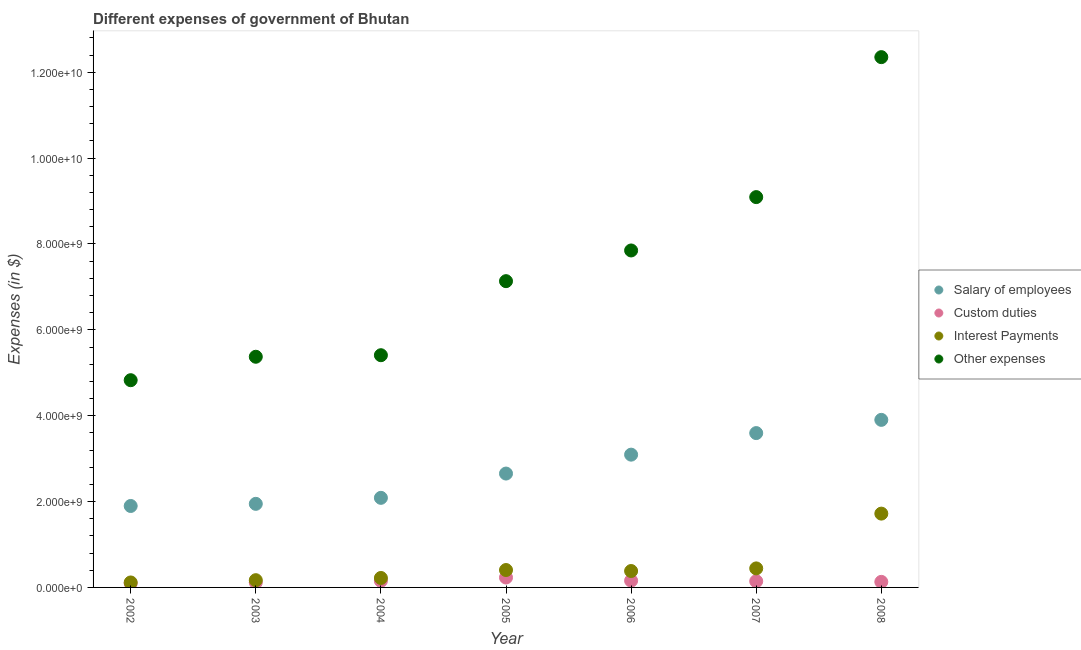What is the amount spent on salary of employees in 2006?
Offer a very short reply. 3.09e+09. Across all years, what is the maximum amount spent on other expenses?
Give a very brief answer. 1.24e+1. Across all years, what is the minimum amount spent on salary of employees?
Provide a succinct answer. 1.90e+09. In which year was the amount spent on interest payments maximum?
Ensure brevity in your answer.  2008. What is the total amount spent on custom duties in the graph?
Provide a succinct answer. 1.03e+09. What is the difference between the amount spent on salary of employees in 2006 and that in 2008?
Offer a very short reply. -8.10e+08. What is the difference between the amount spent on custom duties in 2007 and the amount spent on salary of employees in 2006?
Ensure brevity in your answer.  -2.95e+09. What is the average amount spent on other expenses per year?
Provide a succinct answer. 7.43e+09. In the year 2006, what is the difference between the amount spent on salary of employees and amount spent on interest payments?
Your response must be concise. 2.71e+09. What is the ratio of the amount spent on interest payments in 2004 to that in 2007?
Ensure brevity in your answer.  0.5. Is the amount spent on interest payments in 2005 less than that in 2007?
Keep it short and to the point. Yes. What is the difference between the highest and the second highest amount spent on salary of employees?
Ensure brevity in your answer.  3.08e+08. What is the difference between the highest and the lowest amount spent on salary of employees?
Your answer should be very brief. 2.01e+09. Is the amount spent on salary of employees strictly greater than the amount spent on interest payments over the years?
Provide a succinct answer. Yes. Is the amount spent on custom duties strictly less than the amount spent on other expenses over the years?
Offer a terse response. Yes. How many years are there in the graph?
Give a very brief answer. 7. What is the difference between two consecutive major ticks on the Y-axis?
Offer a very short reply. 2.00e+09. Does the graph contain any zero values?
Your answer should be very brief. No. Where does the legend appear in the graph?
Your answer should be compact. Center right. How many legend labels are there?
Provide a short and direct response. 4. How are the legend labels stacked?
Your answer should be very brief. Vertical. What is the title of the graph?
Offer a terse response. Different expenses of government of Bhutan. Does "Labor Taxes" appear as one of the legend labels in the graph?
Keep it short and to the point. No. What is the label or title of the X-axis?
Make the answer very short. Year. What is the label or title of the Y-axis?
Provide a short and direct response. Expenses (in $). What is the Expenses (in $) in Salary of employees in 2002?
Your answer should be compact. 1.90e+09. What is the Expenses (in $) of Custom duties in 2002?
Your answer should be compact. 9.45e+07. What is the Expenses (in $) of Interest Payments in 2002?
Give a very brief answer. 1.16e+08. What is the Expenses (in $) of Other expenses in 2002?
Make the answer very short. 4.83e+09. What is the Expenses (in $) in Salary of employees in 2003?
Give a very brief answer. 1.95e+09. What is the Expenses (in $) of Custom duties in 2003?
Your response must be concise. 1.15e+08. What is the Expenses (in $) in Interest Payments in 2003?
Offer a terse response. 1.69e+08. What is the Expenses (in $) of Other expenses in 2003?
Your response must be concise. 5.37e+09. What is the Expenses (in $) in Salary of employees in 2004?
Make the answer very short. 2.09e+09. What is the Expenses (in $) in Custom duties in 2004?
Your answer should be compact. 1.53e+08. What is the Expenses (in $) of Interest Payments in 2004?
Your answer should be compact. 2.20e+08. What is the Expenses (in $) of Other expenses in 2004?
Provide a short and direct response. 5.41e+09. What is the Expenses (in $) of Salary of employees in 2005?
Offer a terse response. 2.65e+09. What is the Expenses (in $) of Custom duties in 2005?
Offer a very short reply. 2.31e+08. What is the Expenses (in $) of Interest Payments in 2005?
Offer a terse response. 4.05e+08. What is the Expenses (in $) in Other expenses in 2005?
Your response must be concise. 7.13e+09. What is the Expenses (in $) of Salary of employees in 2006?
Give a very brief answer. 3.09e+09. What is the Expenses (in $) of Custom duties in 2006?
Provide a succinct answer. 1.57e+08. What is the Expenses (in $) of Interest Payments in 2006?
Provide a succinct answer. 3.82e+08. What is the Expenses (in $) in Other expenses in 2006?
Make the answer very short. 7.85e+09. What is the Expenses (in $) in Salary of employees in 2007?
Give a very brief answer. 3.60e+09. What is the Expenses (in $) in Custom duties in 2007?
Keep it short and to the point. 1.45e+08. What is the Expenses (in $) in Interest Payments in 2007?
Make the answer very short. 4.43e+08. What is the Expenses (in $) in Other expenses in 2007?
Give a very brief answer. 9.09e+09. What is the Expenses (in $) in Salary of employees in 2008?
Provide a succinct answer. 3.90e+09. What is the Expenses (in $) in Custom duties in 2008?
Offer a very short reply. 1.29e+08. What is the Expenses (in $) of Interest Payments in 2008?
Provide a short and direct response. 1.72e+09. What is the Expenses (in $) in Other expenses in 2008?
Provide a succinct answer. 1.24e+1. Across all years, what is the maximum Expenses (in $) of Salary of employees?
Provide a short and direct response. 3.90e+09. Across all years, what is the maximum Expenses (in $) in Custom duties?
Give a very brief answer. 2.31e+08. Across all years, what is the maximum Expenses (in $) of Interest Payments?
Provide a succinct answer. 1.72e+09. Across all years, what is the maximum Expenses (in $) in Other expenses?
Provide a short and direct response. 1.24e+1. Across all years, what is the minimum Expenses (in $) in Salary of employees?
Provide a succinct answer. 1.90e+09. Across all years, what is the minimum Expenses (in $) in Custom duties?
Make the answer very short. 9.45e+07. Across all years, what is the minimum Expenses (in $) in Interest Payments?
Provide a succinct answer. 1.16e+08. Across all years, what is the minimum Expenses (in $) of Other expenses?
Ensure brevity in your answer.  4.83e+09. What is the total Expenses (in $) in Salary of employees in the graph?
Your response must be concise. 1.92e+1. What is the total Expenses (in $) in Custom duties in the graph?
Provide a short and direct response. 1.03e+09. What is the total Expenses (in $) of Interest Payments in the graph?
Offer a very short reply. 3.45e+09. What is the total Expenses (in $) in Other expenses in the graph?
Give a very brief answer. 5.20e+1. What is the difference between the Expenses (in $) of Salary of employees in 2002 and that in 2003?
Give a very brief answer. -4.99e+07. What is the difference between the Expenses (in $) of Custom duties in 2002 and that in 2003?
Give a very brief answer. -2.06e+07. What is the difference between the Expenses (in $) of Interest Payments in 2002 and that in 2003?
Your answer should be very brief. -5.31e+07. What is the difference between the Expenses (in $) in Other expenses in 2002 and that in 2003?
Keep it short and to the point. -5.46e+08. What is the difference between the Expenses (in $) in Salary of employees in 2002 and that in 2004?
Your response must be concise. -1.90e+08. What is the difference between the Expenses (in $) of Custom duties in 2002 and that in 2004?
Offer a terse response. -5.88e+07. What is the difference between the Expenses (in $) of Interest Payments in 2002 and that in 2004?
Your answer should be very brief. -1.05e+08. What is the difference between the Expenses (in $) in Other expenses in 2002 and that in 2004?
Provide a short and direct response. -5.82e+08. What is the difference between the Expenses (in $) of Salary of employees in 2002 and that in 2005?
Offer a very short reply. -7.55e+08. What is the difference between the Expenses (in $) of Custom duties in 2002 and that in 2005?
Ensure brevity in your answer.  -1.36e+08. What is the difference between the Expenses (in $) in Interest Payments in 2002 and that in 2005?
Keep it short and to the point. -2.90e+08. What is the difference between the Expenses (in $) in Other expenses in 2002 and that in 2005?
Your answer should be very brief. -2.31e+09. What is the difference between the Expenses (in $) in Salary of employees in 2002 and that in 2006?
Offer a terse response. -1.20e+09. What is the difference between the Expenses (in $) of Custom duties in 2002 and that in 2006?
Ensure brevity in your answer.  -6.27e+07. What is the difference between the Expenses (in $) of Interest Payments in 2002 and that in 2006?
Your response must be concise. -2.66e+08. What is the difference between the Expenses (in $) of Other expenses in 2002 and that in 2006?
Provide a succinct answer. -3.02e+09. What is the difference between the Expenses (in $) in Salary of employees in 2002 and that in 2007?
Give a very brief answer. -1.70e+09. What is the difference between the Expenses (in $) of Custom duties in 2002 and that in 2007?
Ensure brevity in your answer.  -5.02e+07. What is the difference between the Expenses (in $) in Interest Payments in 2002 and that in 2007?
Provide a short and direct response. -3.28e+08. What is the difference between the Expenses (in $) of Other expenses in 2002 and that in 2007?
Give a very brief answer. -4.27e+09. What is the difference between the Expenses (in $) in Salary of employees in 2002 and that in 2008?
Your answer should be very brief. -2.01e+09. What is the difference between the Expenses (in $) of Custom duties in 2002 and that in 2008?
Offer a very short reply. -3.50e+07. What is the difference between the Expenses (in $) of Interest Payments in 2002 and that in 2008?
Provide a succinct answer. -1.60e+09. What is the difference between the Expenses (in $) of Other expenses in 2002 and that in 2008?
Provide a short and direct response. -7.53e+09. What is the difference between the Expenses (in $) in Salary of employees in 2003 and that in 2004?
Your response must be concise. -1.40e+08. What is the difference between the Expenses (in $) of Custom duties in 2003 and that in 2004?
Your response must be concise. -3.82e+07. What is the difference between the Expenses (in $) in Interest Payments in 2003 and that in 2004?
Make the answer very short. -5.14e+07. What is the difference between the Expenses (in $) of Other expenses in 2003 and that in 2004?
Offer a terse response. -3.60e+07. What is the difference between the Expenses (in $) of Salary of employees in 2003 and that in 2005?
Offer a very short reply. -7.05e+08. What is the difference between the Expenses (in $) of Custom duties in 2003 and that in 2005?
Your answer should be compact. -1.16e+08. What is the difference between the Expenses (in $) in Interest Payments in 2003 and that in 2005?
Offer a terse response. -2.37e+08. What is the difference between the Expenses (in $) in Other expenses in 2003 and that in 2005?
Provide a succinct answer. -1.76e+09. What is the difference between the Expenses (in $) in Salary of employees in 2003 and that in 2006?
Give a very brief answer. -1.15e+09. What is the difference between the Expenses (in $) in Custom duties in 2003 and that in 2006?
Your response must be concise. -4.20e+07. What is the difference between the Expenses (in $) of Interest Payments in 2003 and that in 2006?
Provide a succinct answer. -2.13e+08. What is the difference between the Expenses (in $) in Other expenses in 2003 and that in 2006?
Make the answer very short. -2.48e+09. What is the difference between the Expenses (in $) in Salary of employees in 2003 and that in 2007?
Keep it short and to the point. -1.65e+09. What is the difference between the Expenses (in $) of Custom duties in 2003 and that in 2007?
Make the answer very short. -2.95e+07. What is the difference between the Expenses (in $) of Interest Payments in 2003 and that in 2007?
Ensure brevity in your answer.  -2.74e+08. What is the difference between the Expenses (in $) in Other expenses in 2003 and that in 2007?
Ensure brevity in your answer.  -3.72e+09. What is the difference between the Expenses (in $) of Salary of employees in 2003 and that in 2008?
Give a very brief answer. -1.96e+09. What is the difference between the Expenses (in $) of Custom duties in 2003 and that in 2008?
Offer a terse response. -1.43e+07. What is the difference between the Expenses (in $) of Interest Payments in 2003 and that in 2008?
Give a very brief answer. -1.55e+09. What is the difference between the Expenses (in $) of Other expenses in 2003 and that in 2008?
Provide a succinct answer. -6.98e+09. What is the difference between the Expenses (in $) in Salary of employees in 2004 and that in 2005?
Offer a very short reply. -5.66e+08. What is the difference between the Expenses (in $) in Custom duties in 2004 and that in 2005?
Offer a terse response. -7.75e+07. What is the difference between the Expenses (in $) in Interest Payments in 2004 and that in 2005?
Give a very brief answer. -1.85e+08. What is the difference between the Expenses (in $) in Other expenses in 2004 and that in 2005?
Keep it short and to the point. -1.72e+09. What is the difference between the Expenses (in $) in Salary of employees in 2004 and that in 2006?
Offer a very short reply. -1.01e+09. What is the difference between the Expenses (in $) in Custom duties in 2004 and that in 2006?
Provide a short and direct response. -3.86e+06. What is the difference between the Expenses (in $) in Interest Payments in 2004 and that in 2006?
Provide a short and direct response. -1.62e+08. What is the difference between the Expenses (in $) in Other expenses in 2004 and that in 2006?
Keep it short and to the point. -2.44e+09. What is the difference between the Expenses (in $) in Salary of employees in 2004 and that in 2007?
Your answer should be very brief. -1.51e+09. What is the difference between the Expenses (in $) of Custom duties in 2004 and that in 2007?
Offer a terse response. 8.63e+06. What is the difference between the Expenses (in $) in Interest Payments in 2004 and that in 2007?
Make the answer very short. -2.23e+08. What is the difference between the Expenses (in $) of Other expenses in 2004 and that in 2007?
Provide a short and direct response. -3.68e+09. What is the difference between the Expenses (in $) of Salary of employees in 2004 and that in 2008?
Offer a terse response. -1.82e+09. What is the difference between the Expenses (in $) of Custom duties in 2004 and that in 2008?
Give a very brief answer. 2.38e+07. What is the difference between the Expenses (in $) in Interest Payments in 2004 and that in 2008?
Ensure brevity in your answer.  -1.50e+09. What is the difference between the Expenses (in $) in Other expenses in 2004 and that in 2008?
Provide a succinct answer. -6.94e+09. What is the difference between the Expenses (in $) in Salary of employees in 2005 and that in 2006?
Provide a short and direct response. -4.40e+08. What is the difference between the Expenses (in $) in Custom duties in 2005 and that in 2006?
Your answer should be very brief. 7.36e+07. What is the difference between the Expenses (in $) in Interest Payments in 2005 and that in 2006?
Provide a succinct answer. 2.33e+07. What is the difference between the Expenses (in $) in Other expenses in 2005 and that in 2006?
Make the answer very short. -7.15e+08. What is the difference between the Expenses (in $) of Salary of employees in 2005 and that in 2007?
Provide a short and direct response. -9.43e+08. What is the difference between the Expenses (in $) of Custom duties in 2005 and that in 2007?
Provide a short and direct response. 8.61e+07. What is the difference between the Expenses (in $) in Interest Payments in 2005 and that in 2007?
Provide a short and direct response. -3.78e+07. What is the difference between the Expenses (in $) in Other expenses in 2005 and that in 2007?
Offer a terse response. -1.96e+09. What is the difference between the Expenses (in $) in Salary of employees in 2005 and that in 2008?
Give a very brief answer. -1.25e+09. What is the difference between the Expenses (in $) in Custom duties in 2005 and that in 2008?
Your answer should be compact. 1.01e+08. What is the difference between the Expenses (in $) in Interest Payments in 2005 and that in 2008?
Provide a short and direct response. -1.31e+09. What is the difference between the Expenses (in $) in Other expenses in 2005 and that in 2008?
Your answer should be compact. -5.22e+09. What is the difference between the Expenses (in $) of Salary of employees in 2006 and that in 2007?
Provide a short and direct response. -5.02e+08. What is the difference between the Expenses (in $) of Custom duties in 2006 and that in 2007?
Ensure brevity in your answer.  1.25e+07. What is the difference between the Expenses (in $) in Interest Payments in 2006 and that in 2007?
Make the answer very short. -6.12e+07. What is the difference between the Expenses (in $) of Other expenses in 2006 and that in 2007?
Offer a very short reply. -1.24e+09. What is the difference between the Expenses (in $) of Salary of employees in 2006 and that in 2008?
Provide a succinct answer. -8.10e+08. What is the difference between the Expenses (in $) in Custom duties in 2006 and that in 2008?
Offer a terse response. 2.77e+07. What is the difference between the Expenses (in $) in Interest Payments in 2006 and that in 2008?
Keep it short and to the point. -1.34e+09. What is the difference between the Expenses (in $) in Other expenses in 2006 and that in 2008?
Give a very brief answer. -4.50e+09. What is the difference between the Expenses (in $) in Salary of employees in 2007 and that in 2008?
Provide a succinct answer. -3.08e+08. What is the difference between the Expenses (in $) of Custom duties in 2007 and that in 2008?
Your answer should be very brief. 1.52e+07. What is the difference between the Expenses (in $) in Interest Payments in 2007 and that in 2008?
Your response must be concise. -1.28e+09. What is the difference between the Expenses (in $) in Other expenses in 2007 and that in 2008?
Provide a short and direct response. -3.26e+09. What is the difference between the Expenses (in $) of Salary of employees in 2002 and the Expenses (in $) of Custom duties in 2003?
Your answer should be very brief. 1.78e+09. What is the difference between the Expenses (in $) of Salary of employees in 2002 and the Expenses (in $) of Interest Payments in 2003?
Ensure brevity in your answer.  1.73e+09. What is the difference between the Expenses (in $) of Salary of employees in 2002 and the Expenses (in $) of Other expenses in 2003?
Your answer should be very brief. -3.48e+09. What is the difference between the Expenses (in $) in Custom duties in 2002 and the Expenses (in $) in Interest Payments in 2003?
Your answer should be very brief. -7.44e+07. What is the difference between the Expenses (in $) in Custom duties in 2002 and the Expenses (in $) in Other expenses in 2003?
Ensure brevity in your answer.  -5.28e+09. What is the difference between the Expenses (in $) in Interest Payments in 2002 and the Expenses (in $) in Other expenses in 2003?
Make the answer very short. -5.26e+09. What is the difference between the Expenses (in $) in Salary of employees in 2002 and the Expenses (in $) in Custom duties in 2004?
Offer a terse response. 1.74e+09. What is the difference between the Expenses (in $) in Salary of employees in 2002 and the Expenses (in $) in Interest Payments in 2004?
Your response must be concise. 1.68e+09. What is the difference between the Expenses (in $) in Salary of employees in 2002 and the Expenses (in $) in Other expenses in 2004?
Your answer should be compact. -3.51e+09. What is the difference between the Expenses (in $) of Custom duties in 2002 and the Expenses (in $) of Interest Payments in 2004?
Make the answer very short. -1.26e+08. What is the difference between the Expenses (in $) in Custom duties in 2002 and the Expenses (in $) in Other expenses in 2004?
Ensure brevity in your answer.  -5.31e+09. What is the difference between the Expenses (in $) in Interest Payments in 2002 and the Expenses (in $) in Other expenses in 2004?
Keep it short and to the point. -5.29e+09. What is the difference between the Expenses (in $) in Salary of employees in 2002 and the Expenses (in $) in Custom duties in 2005?
Keep it short and to the point. 1.67e+09. What is the difference between the Expenses (in $) in Salary of employees in 2002 and the Expenses (in $) in Interest Payments in 2005?
Offer a very short reply. 1.49e+09. What is the difference between the Expenses (in $) in Salary of employees in 2002 and the Expenses (in $) in Other expenses in 2005?
Provide a short and direct response. -5.24e+09. What is the difference between the Expenses (in $) of Custom duties in 2002 and the Expenses (in $) of Interest Payments in 2005?
Ensure brevity in your answer.  -3.11e+08. What is the difference between the Expenses (in $) of Custom duties in 2002 and the Expenses (in $) of Other expenses in 2005?
Your answer should be compact. -7.04e+09. What is the difference between the Expenses (in $) in Interest Payments in 2002 and the Expenses (in $) in Other expenses in 2005?
Your answer should be very brief. -7.02e+09. What is the difference between the Expenses (in $) of Salary of employees in 2002 and the Expenses (in $) of Custom duties in 2006?
Provide a short and direct response. 1.74e+09. What is the difference between the Expenses (in $) in Salary of employees in 2002 and the Expenses (in $) in Interest Payments in 2006?
Offer a terse response. 1.52e+09. What is the difference between the Expenses (in $) in Salary of employees in 2002 and the Expenses (in $) in Other expenses in 2006?
Provide a succinct answer. -5.95e+09. What is the difference between the Expenses (in $) in Custom duties in 2002 and the Expenses (in $) in Interest Payments in 2006?
Make the answer very short. -2.88e+08. What is the difference between the Expenses (in $) in Custom duties in 2002 and the Expenses (in $) in Other expenses in 2006?
Give a very brief answer. -7.75e+09. What is the difference between the Expenses (in $) in Interest Payments in 2002 and the Expenses (in $) in Other expenses in 2006?
Offer a very short reply. -7.73e+09. What is the difference between the Expenses (in $) of Salary of employees in 2002 and the Expenses (in $) of Custom duties in 2007?
Give a very brief answer. 1.75e+09. What is the difference between the Expenses (in $) in Salary of employees in 2002 and the Expenses (in $) in Interest Payments in 2007?
Your response must be concise. 1.45e+09. What is the difference between the Expenses (in $) in Salary of employees in 2002 and the Expenses (in $) in Other expenses in 2007?
Provide a succinct answer. -7.20e+09. What is the difference between the Expenses (in $) in Custom duties in 2002 and the Expenses (in $) in Interest Payments in 2007?
Make the answer very short. -3.49e+08. What is the difference between the Expenses (in $) in Custom duties in 2002 and the Expenses (in $) in Other expenses in 2007?
Keep it short and to the point. -9.00e+09. What is the difference between the Expenses (in $) in Interest Payments in 2002 and the Expenses (in $) in Other expenses in 2007?
Offer a very short reply. -8.98e+09. What is the difference between the Expenses (in $) in Salary of employees in 2002 and the Expenses (in $) in Custom duties in 2008?
Ensure brevity in your answer.  1.77e+09. What is the difference between the Expenses (in $) in Salary of employees in 2002 and the Expenses (in $) in Interest Payments in 2008?
Your response must be concise. 1.78e+08. What is the difference between the Expenses (in $) of Salary of employees in 2002 and the Expenses (in $) of Other expenses in 2008?
Provide a succinct answer. -1.05e+1. What is the difference between the Expenses (in $) in Custom duties in 2002 and the Expenses (in $) in Interest Payments in 2008?
Make the answer very short. -1.62e+09. What is the difference between the Expenses (in $) in Custom duties in 2002 and the Expenses (in $) in Other expenses in 2008?
Make the answer very short. -1.23e+1. What is the difference between the Expenses (in $) in Interest Payments in 2002 and the Expenses (in $) in Other expenses in 2008?
Keep it short and to the point. -1.22e+1. What is the difference between the Expenses (in $) in Salary of employees in 2003 and the Expenses (in $) in Custom duties in 2004?
Make the answer very short. 1.79e+09. What is the difference between the Expenses (in $) in Salary of employees in 2003 and the Expenses (in $) in Interest Payments in 2004?
Provide a short and direct response. 1.73e+09. What is the difference between the Expenses (in $) of Salary of employees in 2003 and the Expenses (in $) of Other expenses in 2004?
Offer a terse response. -3.46e+09. What is the difference between the Expenses (in $) in Custom duties in 2003 and the Expenses (in $) in Interest Payments in 2004?
Offer a very short reply. -1.05e+08. What is the difference between the Expenses (in $) in Custom duties in 2003 and the Expenses (in $) in Other expenses in 2004?
Ensure brevity in your answer.  -5.29e+09. What is the difference between the Expenses (in $) of Interest Payments in 2003 and the Expenses (in $) of Other expenses in 2004?
Keep it short and to the point. -5.24e+09. What is the difference between the Expenses (in $) of Salary of employees in 2003 and the Expenses (in $) of Custom duties in 2005?
Your answer should be very brief. 1.72e+09. What is the difference between the Expenses (in $) in Salary of employees in 2003 and the Expenses (in $) in Interest Payments in 2005?
Offer a very short reply. 1.54e+09. What is the difference between the Expenses (in $) in Salary of employees in 2003 and the Expenses (in $) in Other expenses in 2005?
Offer a terse response. -5.19e+09. What is the difference between the Expenses (in $) in Custom duties in 2003 and the Expenses (in $) in Interest Payments in 2005?
Offer a very short reply. -2.90e+08. What is the difference between the Expenses (in $) in Custom duties in 2003 and the Expenses (in $) in Other expenses in 2005?
Your answer should be compact. -7.02e+09. What is the difference between the Expenses (in $) of Interest Payments in 2003 and the Expenses (in $) of Other expenses in 2005?
Keep it short and to the point. -6.97e+09. What is the difference between the Expenses (in $) of Salary of employees in 2003 and the Expenses (in $) of Custom duties in 2006?
Your response must be concise. 1.79e+09. What is the difference between the Expenses (in $) of Salary of employees in 2003 and the Expenses (in $) of Interest Payments in 2006?
Keep it short and to the point. 1.56e+09. What is the difference between the Expenses (in $) of Salary of employees in 2003 and the Expenses (in $) of Other expenses in 2006?
Your answer should be compact. -5.90e+09. What is the difference between the Expenses (in $) of Custom duties in 2003 and the Expenses (in $) of Interest Payments in 2006?
Your answer should be compact. -2.67e+08. What is the difference between the Expenses (in $) in Custom duties in 2003 and the Expenses (in $) in Other expenses in 2006?
Keep it short and to the point. -7.73e+09. What is the difference between the Expenses (in $) of Interest Payments in 2003 and the Expenses (in $) of Other expenses in 2006?
Provide a succinct answer. -7.68e+09. What is the difference between the Expenses (in $) of Salary of employees in 2003 and the Expenses (in $) of Custom duties in 2007?
Offer a very short reply. 1.80e+09. What is the difference between the Expenses (in $) of Salary of employees in 2003 and the Expenses (in $) of Interest Payments in 2007?
Offer a terse response. 1.50e+09. What is the difference between the Expenses (in $) in Salary of employees in 2003 and the Expenses (in $) in Other expenses in 2007?
Your response must be concise. -7.15e+09. What is the difference between the Expenses (in $) in Custom duties in 2003 and the Expenses (in $) in Interest Payments in 2007?
Your answer should be very brief. -3.28e+08. What is the difference between the Expenses (in $) of Custom duties in 2003 and the Expenses (in $) of Other expenses in 2007?
Make the answer very short. -8.98e+09. What is the difference between the Expenses (in $) of Interest Payments in 2003 and the Expenses (in $) of Other expenses in 2007?
Make the answer very short. -8.92e+09. What is the difference between the Expenses (in $) in Salary of employees in 2003 and the Expenses (in $) in Custom duties in 2008?
Your answer should be very brief. 1.82e+09. What is the difference between the Expenses (in $) in Salary of employees in 2003 and the Expenses (in $) in Interest Payments in 2008?
Your answer should be very brief. 2.28e+08. What is the difference between the Expenses (in $) of Salary of employees in 2003 and the Expenses (in $) of Other expenses in 2008?
Your answer should be very brief. -1.04e+1. What is the difference between the Expenses (in $) of Custom duties in 2003 and the Expenses (in $) of Interest Payments in 2008?
Make the answer very short. -1.60e+09. What is the difference between the Expenses (in $) in Custom duties in 2003 and the Expenses (in $) in Other expenses in 2008?
Your response must be concise. -1.22e+1. What is the difference between the Expenses (in $) in Interest Payments in 2003 and the Expenses (in $) in Other expenses in 2008?
Provide a succinct answer. -1.22e+1. What is the difference between the Expenses (in $) in Salary of employees in 2004 and the Expenses (in $) in Custom duties in 2005?
Offer a terse response. 1.86e+09. What is the difference between the Expenses (in $) in Salary of employees in 2004 and the Expenses (in $) in Interest Payments in 2005?
Offer a very short reply. 1.68e+09. What is the difference between the Expenses (in $) of Salary of employees in 2004 and the Expenses (in $) of Other expenses in 2005?
Offer a terse response. -5.05e+09. What is the difference between the Expenses (in $) in Custom duties in 2004 and the Expenses (in $) in Interest Payments in 2005?
Ensure brevity in your answer.  -2.52e+08. What is the difference between the Expenses (in $) in Custom duties in 2004 and the Expenses (in $) in Other expenses in 2005?
Give a very brief answer. -6.98e+09. What is the difference between the Expenses (in $) of Interest Payments in 2004 and the Expenses (in $) of Other expenses in 2005?
Keep it short and to the point. -6.91e+09. What is the difference between the Expenses (in $) in Salary of employees in 2004 and the Expenses (in $) in Custom duties in 2006?
Ensure brevity in your answer.  1.93e+09. What is the difference between the Expenses (in $) of Salary of employees in 2004 and the Expenses (in $) of Interest Payments in 2006?
Offer a very short reply. 1.70e+09. What is the difference between the Expenses (in $) of Salary of employees in 2004 and the Expenses (in $) of Other expenses in 2006?
Your response must be concise. -5.76e+09. What is the difference between the Expenses (in $) of Custom duties in 2004 and the Expenses (in $) of Interest Payments in 2006?
Your answer should be compact. -2.29e+08. What is the difference between the Expenses (in $) in Custom duties in 2004 and the Expenses (in $) in Other expenses in 2006?
Make the answer very short. -7.70e+09. What is the difference between the Expenses (in $) of Interest Payments in 2004 and the Expenses (in $) of Other expenses in 2006?
Offer a very short reply. -7.63e+09. What is the difference between the Expenses (in $) of Salary of employees in 2004 and the Expenses (in $) of Custom duties in 2007?
Give a very brief answer. 1.94e+09. What is the difference between the Expenses (in $) in Salary of employees in 2004 and the Expenses (in $) in Interest Payments in 2007?
Offer a very short reply. 1.64e+09. What is the difference between the Expenses (in $) of Salary of employees in 2004 and the Expenses (in $) of Other expenses in 2007?
Offer a terse response. -7.01e+09. What is the difference between the Expenses (in $) in Custom duties in 2004 and the Expenses (in $) in Interest Payments in 2007?
Offer a very short reply. -2.90e+08. What is the difference between the Expenses (in $) in Custom duties in 2004 and the Expenses (in $) in Other expenses in 2007?
Ensure brevity in your answer.  -8.94e+09. What is the difference between the Expenses (in $) in Interest Payments in 2004 and the Expenses (in $) in Other expenses in 2007?
Keep it short and to the point. -8.87e+09. What is the difference between the Expenses (in $) of Salary of employees in 2004 and the Expenses (in $) of Custom duties in 2008?
Offer a terse response. 1.96e+09. What is the difference between the Expenses (in $) of Salary of employees in 2004 and the Expenses (in $) of Interest Payments in 2008?
Give a very brief answer. 3.68e+08. What is the difference between the Expenses (in $) in Salary of employees in 2004 and the Expenses (in $) in Other expenses in 2008?
Offer a terse response. -1.03e+1. What is the difference between the Expenses (in $) in Custom duties in 2004 and the Expenses (in $) in Interest Payments in 2008?
Offer a very short reply. -1.57e+09. What is the difference between the Expenses (in $) in Custom duties in 2004 and the Expenses (in $) in Other expenses in 2008?
Your answer should be very brief. -1.22e+1. What is the difference between the Expenses (in $) in Interest Payments in 2004 and the Expenses (in $) in Other expenses in 2008?
Your response must be concise. -1.21e+1. What is the difference between the Expenses (in $) of Salary of employees in 2005 and the Expenses (in $) of Custom duties in 2006?
Your response must be concise. 2.50e+09. What is the difference between the Expenses (in $) in Salary of employees in 2005 and the Expenses (in $) in Interest Payments in 2006?
Your answer should be very brief. 2.27e+09. What is the difference between the Expenses (in $) of Salary of employees in 2005 and the Expenses (in $) of Other expenses in 2006?
Offer a terse response. -5.20e+09. What is the difference between the Expenses (in $) of Custom duties in 2005 and the Expenses (in $) of Interest Payments in 2006?
Ensure brevity in your answer.  -1.51e+08. What is the difference between the Expenses (in $) in Custom duties in 2005 and the Expenses (in $) in Other expenses in 2006?
Provide a short and direct response. -7.62e+09. What is the difference between the Expenses (in $) in Interest Payments in 2005 and the Expenses (in $) in Other expenses in 2006?
Offer a terse response. -7.44e+09. What is the difference between the Expenses (in $) in Salary of employees in 2005 and the Expenses (in $) in Custom duties in 2007?
Offer a terse response. 2.51e+09. What is the difference between the Expenses (in $) in Salary of employees in 2005 and the Expenses (in $) in Interest Payments in 2007?
Provide a succinct answer. 2.21e+09. What is the difference between the Expenses (in $) in Salary of employees in 2005 and the Expenses (in $) in Other expenses in 2007?
Provide a short and direct response. -6.44e+09. What is the difference between the Expenses (in $) in Custom duties in 2005 and the Expenses (in $) in Interest Payments in 2007?
Ensure brevity in your answer.  -2.13e+08. What is the difference between the Expenses (in $) in Custom duties in 2005 and the Expenses (in $) in Other expenses in 2007?
Make the answer very short. -8.86e+09. What is the difference between the Expenses (in $) in Interest Payments in 2005 and the Expenses (in $) in Other expenses in 2007?
Provide a short and direct response. -8.69e+09. What is the difference between the Expenses (in $) in Salary of employees in 2005 and the Expenses (in $) in Custom duties in 2008?
Offer a very short reply. 2.52e+09. What is the difference between the Expenses (in $) of Salary of employees in 2005 and the Expenses (in $) of Interest Payments in 2008?
Make the answer very short. 9.33e+08. What is the difference between the Expenses (in $) in Salary of employees in 2005 and the Expenses (in $) in Other expenses in 2008?
Ensure brevity in your answer.  -9.70e+09. What is the difference between the Expenses (in $) of Custom duties in 2005 and the Expenses (in $) of Interest Payments in 2008?
Your answer should be compact. -1.49e+09. What is the difference between the Expenses (in $) of Custom duties in 2005 and the Expenses (in $) of Other expenses in 2008?
Provide a short and direct response. -1.21e+1. What is the difference between the Expenses (in $) of Interest Payments in 2005 and the Expenses (in $) of Other expenses in 2008?
Make the answer very short. -1.19e+1. What is the difference between the Expenses (in $) in Salary of employees in 2006 and the Expenses (in $) in Custom duties in 2007?
Give a very brief answer. 2.95e+09. What is the difference between the Expenses (in $) in Salary of employees in 2006 and the Expenses (in $) in Interest Payments in 2007?
Offer a very short reply. 2.65e+09. What is the difference between the Expenses (in $) of Salary of employees in 2006 and the Expenses (in $) of Other expenses in 2007?
Provide a succinct answer. -6.00e+09. What is the difference between the Expenses (in $) in Custom duties in 2006 and the Expenses (in $) in Interest Payments in 2007?
Provide a succinct answer. -2.86e+08. What is the difference between the Expenses (in $) of Custom duties in 2006 and the Expenses (in $) of Other expenses in 2007?
Provide a short and direct response. -8.93e+09. What is the difference between the Expenses (in $) in Interest Payments in 2006 and the Expenses (in $) in Other expenses in 2007?
Your answer should be very brief. -8.71e+09. What is the difference between the Expenses (in $) in Salary of employees in 2006 and the Expenses (in $) in Custom duties in 2008?
Keep it short and to the point. 2.96e+09. What is the difference between the Expenses (in $) in Salary of employees in 2006 and the Expenses (in $) in Interest Payments in 2008?
Offer a terse response. 1.37e+09. What is the difference between the Expenses (in $) in Salary of employees in 2006 and the Expenses (in $) in Other expenses in 2008?
Make the answer very short. -9.26e+09. What is the difference between the Expenses (in $) of Custom duties in 2006 and the Expenses (in $) of Interest Payments in 2008?
Give a very brief answer. -1.56e+09. What is the difference between the Expenses (in $) in Custom duties in 2006 and the Expenses (in $) in Other expenses in 2008?
Ensure brevity in your answer.  -1.22e+1. What is the difference between the Expenses (in $) in Interest Payments in 2006 and the Expenses (in $) in Other expenses in 2008?
Your response must be concise. -1.20e+1. What is the difference between the Expenses (in $) in Salary of employees in 2007 and the Expenses (in $) in Custom duties in 2008?
Make the answer very short. 3.47e+09. What is the difference between the Expenses (in $) of Salary of employees in 2007 and the Expenses (in $) of Interest Payments in 2008?
Keep it short and to the point. 1.88e+09. What is the difference between the Expenses (in $) of Salary of employees in 2007 and the Expenses (in $) of Other expenses in 2008?
Ensure brevity in your answer.  -8.76e+09. What is the difference between the Expenses (in $) of Custom duties in 2007 and the Expenses (in $) of Interest Payments in 2008?
Your answer should be very brief. -1.57e+09. What is the difference between the Expenses (in $) in Custom duties in 2007 and the Expenses (in $) in Other expenses in 2008?
Ensure brevity in your answer.  -1.22e+1. What is the difference between the Expenses (in $) in Interest Payments in 2007 and the Expenses (in $) in Other expenses in 2008?
Make the answer very short. -1.19e+1. What is the average Expenses (in $) of Salary of employees per year?
Ensure brevity in your answer.  2.74e+09. What is the average Expenses (in $) in Custom duties per year?
Offer a terse response. 1.46e+08. What is the average Expenses (in $) of Interest Payments per year?
Provide a succinct answer. 4.94e+08. What is the average Expenses (in $) of Other expenses per year?
Make the answer very short. 7.43e+09. In the year 2002, what is the difference between the Expenses (in $) of Salary of employees and Expenses (in $) of Custom duties?
Provide a succinct answer. 1.80e+09. In the year 2002, what is the difference between the Expenses (in $) of Salary of employees and Expenses (in $) of Interest Payments?
Give a very brief answer. 1.78e+09. In the year 2002, what is the difference between the Expenses (in $) in Salary of employees and Expenses (in $) in Other expenses?
Give a very brief answer. -2.93e+09. In the year 2002, what is the difference between the Expenses (in $) of Custom duties and Expenses (in $) of Interest Payments?
Offer a very short reply. -2.12e+07. In the year 2002, what is the difference between the Expenses (in $) in Custom duties and Expenses (in $) in Other expenses?
Your answer should be compact. -4.73e+09. In the year 2002, what is the difference between the Expenses (in $) in Interest Payments and Expenses (in $) in Other expenses?
Keep it short and to the point. -4.71e+09. In the year 2003, what is the difference between the Expenses (in $) of Salary of employees and Expenses (in $) of Custom duties?
Offer a terse response. 1.83e+09. In the year 2003, what is the difference between the Expenses (in $) of Salary of employees and Expenses (in $) of Interest Payments?
Provide a succinct answer. 1.78e+09. In the year 2003, what is the difference between the Expenses (in $) of Salary of employees and Expenses (in $) of Other expenses?
Your answer should be very brief. -3.43e+09. In the year 2003, what is the difference between the Expenses (in $) of Custom duties and Expenses (in $) of Interest Payments?
Ensure brevity in your answer.  -5.37e+07. In the year 2003, what is the difference between the Expenses (in $) in Custom duties and Expenses (in $) in Other expenses?
Make the answer very short. -5.26e+09. In the year 2003, what is the difference between the Expenses (in $) in Interest Payments and Expenses (in $) in Other expenses?
Ensure brevity in your answer.  -5.20e+09. In the year 2004, what is the difference between the Expenses (in $) of Salary of employees and Expenses (in $) of Custom duties?
Offer a very short reply. 1.93e+09. In the year 2004, what is the difference between the Expenses (in $) of Salary of employees and Expenses (in $) of Interest Payments?
Your answer should be compact. 1.87e+09. In the year 2004, what is the difference between the Expenses (in $) of Salary of employees and Expenses (in $) of Other expenses?
Offer a terse response. -3.32e+09. In the year 2004, what is the difference between the Expenses (in $) of Custom duties and Expenses (in $) of Interest Payments?
Your answer should be very brief. -6.69e+07. In the year 2004, what is the difference between the Expenses (in $) of Custom duties and Expenses (in $) of Other expenses?
Keep it short and to the point. -5.26e+09. In the year 2004, what is the difference between the Expenses (in $) of Interest Payments and Expenses (in $) of Other expenses?
Offer a terse response. -5.19e+09. In the year 2005, what is the difference between the Expenses (in $) in Salary of employees and Expenses (in $) in Custom duties?
Give a very brief answer. 2.42e+09. In the year 2005, what is the difference between the Expenses (in $) in Salary of employees and Expenses (in $) in Interest Payments?
Give a very brief answer. 2.25e+09. In the year 2005, what is the difference between the Expenses (in $) of Salary of employees and Expenses (in $) of Other expenses?
Your answer should be very brief. -4.48e+09. In the year 2005, what is the difference between the Expenses (in $) of Custom duties and Expenses (in $) of Interest Payments?
Ensure brevity in your answer.  -1.75e+08. In the year 2005, what is the difference between the Expenses (in $) of Custom duties and Expenses (in $) of Other expenses?
Your answer should be compact. -6.90e+09. In the year 2005, what is the difference between the Expenses (in $) of Interest Payments and Expenses (in $) of Other expenses?
Keep it short and to the point. -6.73e+09. In the year 2006, what is the difference between the Expenses (in $) in Salary of employees and Expenses (in $) in Custom duties?
Offer a very short reply. 2.94e+09. In the year 2006, what is the difference between the Expenses (in $) in Salary of employees and Expenses (in $) in Interest Payments?
Offer a terse response. 2.71e+09. In the year 2006, what is the difference between the Expenses (in $) of Salary of employees and Expenses (in $) of Other expenses?
Provide a short and direct response. -4.76e+09. In the year 2006, what is the difference between the Expenses (in $) in Custom duties and Expenses (in $) in Interest Payments?
Provide a short and direct response. -2.25e+08. In the year 2006, what is the difference between the Expenses (in $) in Custom duties and Expenses (in $) in Other expenses?
Your answer should be compact. -7.69e+09. In the year 2006, what is the difference between the Expenses (in $) in Interest Payments and Expenses (in $) in Other expenses?
Give a very brief answer. -7.47e+09. In the year 2007, what is the difference between the Expenses (in $) of Salary of employees and Expenses (in $) of Custom duties?
Make the answer very short. 3.45e+09. In the year 2007, what is the difference between the Expenses (in $) in Salary of employees and Expenses (in $) in Interest Payments?
Your answer should be compact. 3.15e+09. In the year 2007, what is the difference between the Expenses (in $) in Salary of employees and Expenses (in $) in Other expenses?
Provide a short and direct response. -5.50e+09. In the year 2007, what is the difference between the Expenses (in $) in Custom duties and Expenses (in $) in Interest Payments?
Provide a short and direct response. -2.99e+08. In the year 2007, what is the difference between the Expenses (in $) of Custom duties and Expenses (in $) of Other expenses?
Keep it short and to the point. -8.95e+09. In the year 2007, what is the difference between the Expenses (in $) of Interest Payments and Expenses (in $) of Other expenses?
Give a very brief answer. -8.65e+09. In the year 2008, what is the difference between the Expenses (in $) of Salary of employees and Expenses (in $) of Custom duties?
Offer a very short reply. 3.77e+09. In the year 2008, what is the difference between the Expenses (in $) in Salary of employees and Expenses (in $) in Interest Payments?
Keep it short and to the point. 2.18e+09. In the year 2008, what is the difference between the Expenses (in $) of Salary of employees and Expenses (in $) of Other expenses?
Your answer should be very brief. -8.45e+09. In the year 2008, what is the difference between the Expenses (in $) of Custom duties and Expenses (in $) of Interest Payments?
Keep it short and to the point. -1.59e+09. In the year 2008, what is the difference between the Expenses (in $) in Custom duties and Expenses (in $) in Other expenses?
Make the answer very short. -1.22e+1. In the year 2008, what is the difference between the Expenses (in $) of Interest Payments and Expenses (in $) of Other expenses?
Offer a terse response. -1.06e+1. What is the ratio of the Expenses (in $) in Salary of employees in 2002 to that in 2003?
Provide a short and direct response. 0.97. What is the ratio of the Expenses (in $) of Custom duties in 2002 to that in 2003?
Your response must be concise. 0.82. What is the ratio of the Expenses (in $) in Interest Payments in 2002 to that in 2003?
Your answer should be very brief. 0.69. What is the ratio of the Expenses (in $) of Other expenses in 2002 to that in 2003?
Provide a succinct answer. 0.9. What is the ratio of the Expenses (in $) in Custom duties in 2002 to that in 2004?
Keep it short and to the point. 0.62. What is the ratio of the Expenses (in $) in Interest Payments in 2002 to that in 2004?
Give a very brief answer. 0.53. What is the ratio of the Expenses (in $) in Other expenses in 2002 to that in 2004?
Ensure brevity in your answer.  0.89. What is the ratio of the Expenses (in $) of Salary of employees in 2002 to that in 2005?
Your answer should be compact. 0.72. What is the ratio of the Expenses (in $) of Custom duties in 2002 to that in 2005?
Your answer should be very brief. 0.41. What is the ratio of the Expenses (in $) of Interest Payments in 2002 to that in 2005?
Your response must be concise. 0.29. What is the ratio of the Expenses (in $) in Other expenses in 2002 to that in 2005?
Your answer should be very brief. 0.68. What is the ratio of the Expenses (in $) in Salary of employees in 2002 to that in 2006?
Provide a short and direct response. 0.61. What is the ratio of the Expenses (in $) of Custom duties in 2002 to that in 2006?
Make the answer very short. 0.6. What is the ratio of the Expenses (in $) of Interest Payments in 2002 to that in 2006?
Keep it short and to the point. 0.3. What is the ratio of the Expenses (in $) of Other expenses in 2002 to that in 2006?
Provide a succinct answer. 0.61. What is the ratio of the Expenses (in $) in Salary of employees in 2002 to that in 2007?
Your answer should be very brief. 0.53. What is the ratio of the Expenses (in $) of Custom duties in 2002 to that in 2007?
Your response must be concise. 0.65. What is the ratio of the Expenses (in $) of Interest Payments in 2002 to that in 2007?
Give a very brief answer. 0.26. What is the ratio of the Expenses (in $) of Other expenses in 2002 to that in 2007?
Provide a succinct answer. 0.53. What is the ratio of the Expenses (in $) of Salary of employees in 2002 to that in 2008?
Ensure brevity in your answer.  0.49. What is the ratio of the Expenses (in $) of Custom duties in 2002 to that in 2008?
Offer a very short reply. 0.73. What is the ratio of the Expenses (in $) of Interest Payments in 2002 to that in 2008?
Your answer should be compact. 0.07. What is the ratio of the Expenses (in $) in Other expenses in 2002 to that in 2008?
Offer a very short reply. 0.39. What is the ratio of the Expenses (in $) in Salary of employees in 2003 to that in 2004?
Ensure brevity in your answer.  0.93. What is the ratio of the Expenses (in $) in Custom duties in 2003 to that in 2004?
Your response must be concise. 0.75. What is the ratio of the Expenses (in $) of Interest Payments in 2003 to that in 2004?
Provide a succinct answer. 0.77. What is the ratio of the Expenses (in $) of Other expenses in 2003 to that in 2004?
Offer a terse response. 0.99. What is the ratio of the Expenses (in $) of Salary of employees in 2003 to that in 2005?
Provide a short and direct response. 0.73. What is the ratio of the Expenses (in $) of Custom duties in 2003 to that in 2005?
Give a very brief answer. 0.5. What is the ratio of the Expenses (in $) in Interest Payments in 2003 to that in 2005?
Provide a short and direct response. 0.42. What is the ratio of the Expenses (in $) of Other expenses in 2003 to that in 2005?
Your response must be concise. 0.75. What is the ratio of the Expenses (in $) of Salary of employees in 2003 to that in 2006?
Offer a very short reply. 0.63. What is the ratio of the Expenses (in $) in Custom duties in 2003 to that in 2006?
Provide a succinct answer. 0.73. What is the ratio of the Expenses (in $) in Interest Payments in 2003 to that in 2006?
Your response must be concise. 0.44. What is the ratio of the Expenses (in $) of Other expenses in 2003 to that in 2006?
Keep it short and to the point. 0.68. What is the ratio of the Expenses (in $) in Salary of employees in 2003 to that in 2007?
Your answer should be very brief. 0.54. What is the ratio of the Expenses (in $) in Custom duties in 2003 to that in 2007?
Your answer should be very brief. 0.8. What is the ratio of the Expenses (in $) of Interest Payments in 2003 to that in 2007?
Offer a terse response. 0.38. What is the ratio of the Expenses (in $) of Other expenses in 2003 to that in 2007?
Keep it short and to the point. 0.59. What is the ratio of the Expenses (in $) of Salary of employees in 2003 to that in 2008?
Give a very brief answer. 0.5. What is the ratio of the Expenses (in $) in Custom duties in 2003 to that in 2008?
Provide a short and direct response. 0.89. What is the ratio of the Expenses (in $) of Interest Payments in 2003 to that in 2008?
Your answer should be compact. 0.1. What is the ratio of the Expenses (in $) of Other expenses in 2003 to that in 2008?
Ensure brevity in your answer.  0.43. What is the ratio of the Expenses (in $) of Salary of employees in 2004 to that in 2005?
Offer a very short reply. 0.79. What is the ratio of the Expenses (in $) of Custom duties in 2004 to that in 2005?
Offer a very short reply. 0.66. What is the ratio of the Expenses (in $) in Interest Payments in 2004 to that in 2005?
Give a very brief answer. 0.54. What is the ratio of the Expenses (in $) in Other expenses in 2004 to that in 2005?
Provide a succinct answer. 0.76. What is the ratio of the Expenses (in $) in Salary of employees in 2004 to that in 2006?
Your answer should be very brief. 0.67. What is the ratio of the Expenses (in $) in Custom duties in 2004 to that in 2006?
Give a very brief answer. 0.98. What is the ratio of the Expenses (in $) in Interest Payments in 2004 to that in 2006?
Your answer should be very brief. 0.58. What is the ratio of the Expenses (in $) of Other expenses in 2004 to that in 2006?
Provide a short and direct response. 0.69. What is the ratio of the Expenses (in $) of Salary of employees in 2004 to that in 2007?
Keep it short and to the point. 0.58. What is the ratio of the Expenses (in $) in Custom duties in 2004 to that in 2007?
Make the answer very short. 1.06. What is the ratio of the Expenses (in $) in Interest Payments in 2004 to that in 2007?
Give a very brief answer. 0.5. What is the ratio of the Expenses (in $) in Other expenses in 2004 to that in 2007?
Offer a very short reply. 0.59. What is the ratio of the Expenses (in $) in Salary of employees in 2004 to that in 2008?
Keep it short and to the point. 0.53. What is the ratio of the Expenses (in $) of Custom duties in 2004 to that in 2008?
Give a very brief answer. 1.18. What is the ratio of the Expenses (in $) of Interest Payments in 2004 to that in 2008?
Your answer should be very brief. 0.13. What is the ratio of the Expenses (in $) of Other expenses in 2004 to that in 2008?
Your answer should be compact. 0.44. What is the ratio of the Expenses (in $) of Salary of employees in 2005 to that in 2006?
Provide a succinct answer. 0.86. What is the ratio of the Expenses (in $) in Custom duties in 2005 to that in 2006?
Your answer should be very brief. 1.47. What is the ratio of the Expenses (in $) of Interest Payments in 2005 to that in 2006?
Provide a succinct answer. 1.06. What is the ratio of the Expenses (in $) of Other expenses in 2005 to that in 2006?
Give a very brief answer. 0.91. What is the ratio of the Expenses (in $) of Salary of employees in 2005 to that in 2007?
Keep it short and to the point. 0.74. What is the ratio of the Expenses (in $) in Custom duties in 2005 to that in 2007?
Make the answer very short. 1.59. What is the ratio of the Expenses (in $) of Interest Payments in 2005 to that in 2007?
Provide a short and direct response. 0.91. What is the ratio of the Expenses (in $) of Other expenses in 2005 to that in 2007?
Offer a terse response. 0.78. What is the ratio of the Expenses (in $) in Salary of employees in 2005 to that in 2008?
Your answer should be very brief. 0.68. What is the ratio of the Expenses (in $) in Custom duties in 2005 to that in 2008?
Keep it short and to the point. 1.78. What is the ratio of the Expenses (in $) in Interest Payments in 2005 to that in 2008?
Your answer should be compact. 0.24. What is the ratio of the Expenses (in $) in Other expenses in 2005 to that in 2008?
Give a very brief answer. 0.58. What is the ratio of the Expenses (in $) in Salary of employees in 2006 to that in 2007?
Keep it short and to the point. 0.86. What is the ratio of the Expenses (in $) in Custom duties in 2006 to that in 2007?
Make the answer very short. 1.09. What is the ratio of the Expenses (in $) in Interest Payments in 2006 to that in 2007?
Ensure brevity in your answer.  0.86. What is the ratio of the Expenses (in $) of Other expenses in 2006 to that in 2007?
Offer a terse response. 0.86. What is the ratio of the Expenses (in $) of Salary of employees in 2006 to that in 2008?
Your answer should be compact. 0.79. What is the ratio of the Expenses (in $) in Custom duties in 2006 to that in 2008?
Your answer should be compact. 1.21. What is the ratio of the Expenses (in $) of Interest Payments in 2006 to that in 2008?
Your answer should be compact. 0.22. What is the ratio of the Expenses (in $) of Other expenses in 2006 to that in 2008?
Provide a succinct answer. 0.64. What is the ratio of the Expenses (in $) in Salary of employees in 2007 to that in 2008?
Keep it short and to the point. 0.92. What is the ratio of the Expenses (in $) of Custom duties in 2007 to that in 2008?
Your response must be concise. 1.12. What is the ratio of the Expenses (in $) in Interest Payments in 2007 to that in 2008?
Ensure brevity in your answer.  0.26. What is the ratio of the Expenses (in $) in Other expenses in 2007 to that in 2008?
Ensure brevity in your answer.  0.74. What is the difference between the highest and the second highest Expenses (in $) in Salary of employees?
Provide a succinct answer. 3.08e+08. What is the difference between the highest and the second highest Expenses (in $) in Custom duties?
Offer a very short reply. 7.36e+07. What is the difference between the highest and the second highest Expenses (in $) of Interest Payments?
Your answer should be very brief. 1.28e+09. What is the difference between the highest and the second highest Expenses (in $) of Other expenses?
Provide a short and direct response. 3.26e+09. What is the difference between the highest and the lowest Expenses (in $) in Salary of employees?
Keep it short and to the point. 2.01e+09. What is the difference between the highest and the lowest Expenses (in $) in Custom duties?
Your answer should be compact. 1.36e+08. What is the difference between the highest and the lowest Expenses (in $) in Interest Payments?
Your answer should be compact. 1.60e+09. What is the difference between the highest and the lowest Expenses (in $) in Other expenses?
Offer a very short reply. 7.53e+09. 